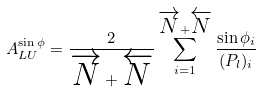Convert formula to latex. <formula><loc_0><loc_0><loc_500><loc_500>A _ { L U } ^ { \sin \phi } = \frac { 2 } { \overrightarrow { N } + \overleftarrow { N } } \sum _ { i = 1 } ^ { \overrightarrow { N } + \overleftarrow { N } } \frac { \sin \phi _ { i } } { ( P _ { l } ) _ { i } }</formula> 